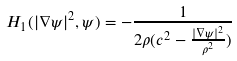<formula> <loc_0><loc_0><loc_500><loc_500>H _ { 1 } ( | \nabla \psi | ^ { 2 } , \psi ) = - \frac { 1 } { 2 \rho ( c ^ { 2 } - \frac { | \nabla \psi | ^ { 2 } } { \rho ^ { 2 } } ) }</formula> 